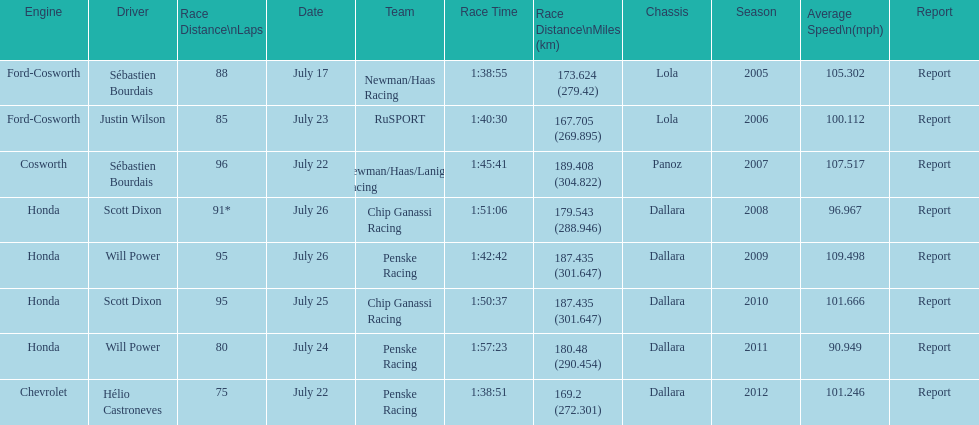How many different teams are represented in the table? 4. 